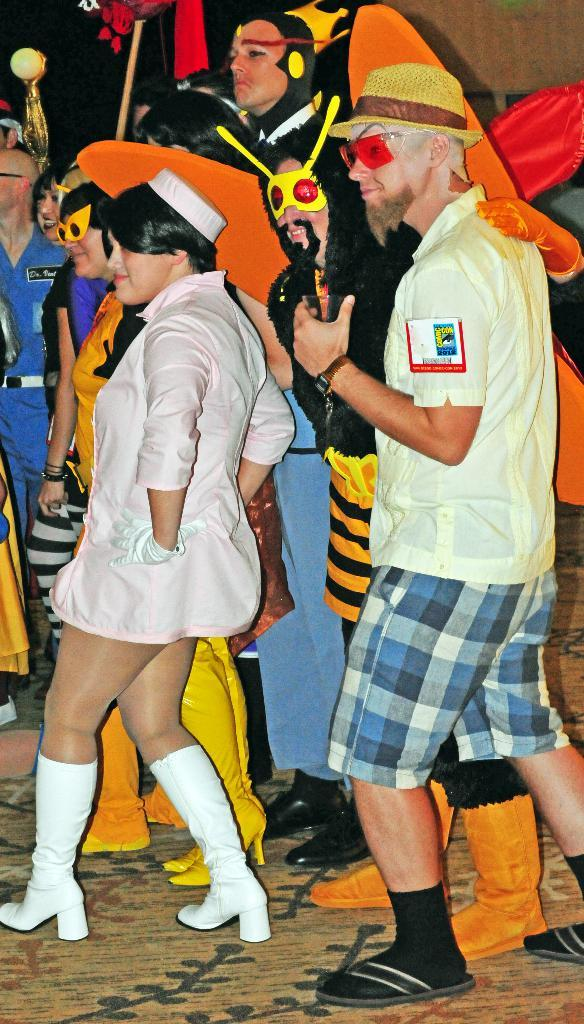How many people are in the image? There are two people in the image. What expressions do the people have? Both people are smiling. Are the people dressed in any specific attire? Some people in the image are wearing costumes. What surface are the people standing on? The people are standing on the ground. What can be seen in the background of the image? There are objects visible in the background of the image. What type of ornament is hanging from the hydrant in the image? There is no hydrant or ornament present in the image. What is being exchanged between the people in the image? The image does not show any exchange between the people; they are simply standing and smiling. 